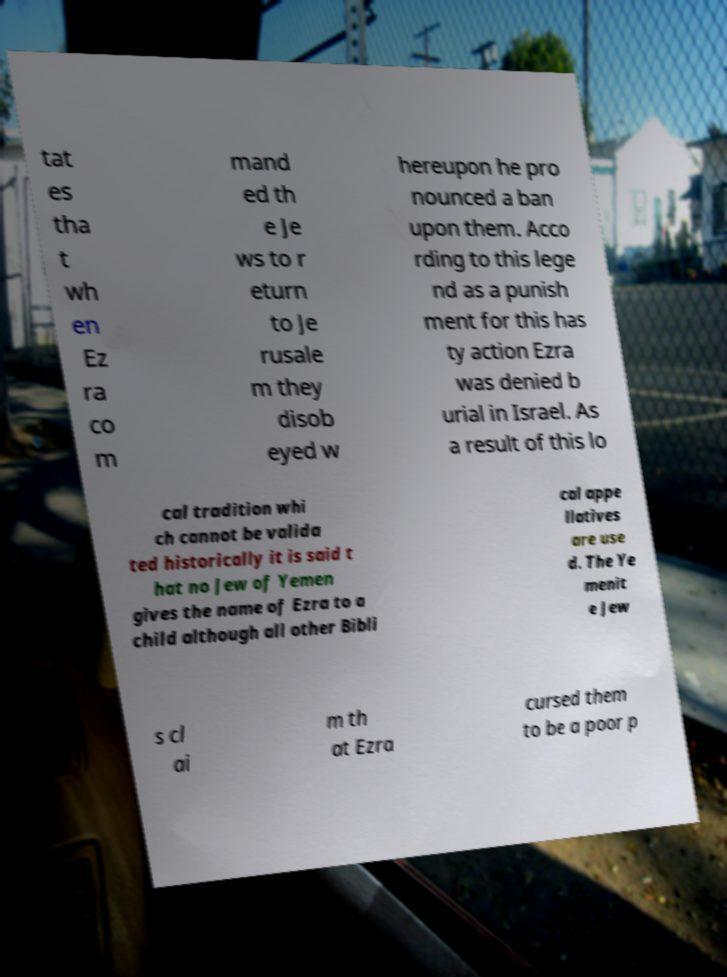Please read and relay the text visible in this image. What does it say? tat es tha t wh en Ez ra co m mand ed th e Je ws to r eturn to Je rusale m they disob eyed w hereupon he pro nounced a ban upon them. Acco rding to this lege nd as a punish ment for this has ty action Ezra was denied b urial in Israel. As a result of this lo cal tradition whi ch cannot be valida ted historically it is said t hat no Jew of Yemen gives the name of Ezra to a child although all other Bibli cal appe llatives are use d. The Ye menit e Jew s cl ai m th at Ezra cursed them to be a poor p 